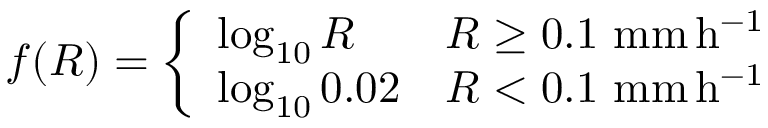Convert formula to latex. <formula><loc_0><loc_0><loc_500><loc_500>f ( R ) = \left \{ \begin{array} { l l } { \log _ { 1 0 } R } & { R \geq 0 . 1 \ m m \, h ^ { - 1 } } \\ { \log _ { 1 0 } 0 . 0 2 } & { R < 0 . 1 \ m m \, h ^ { - 1 } } \end{array}</formula> 